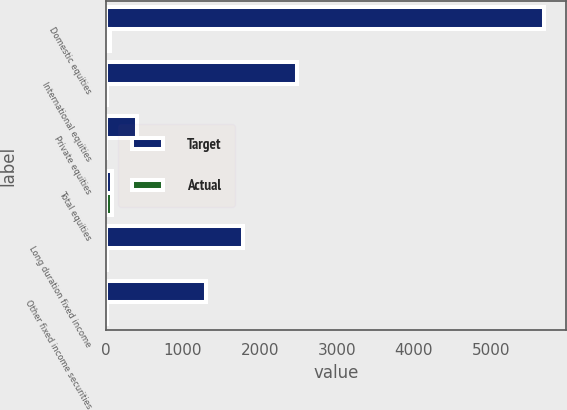<chart> <loc_0><loc_0><loc_500><loc_500><stacked_bar_chart><ecel><fcel>Domestic equities<fcel>International equities<fcel>Private equities<fcel>Total equities<fcel>Long duration fixed income<fcel>Other fixed income securities<nl><fcel>Target<fcel>5694<fcel>2481<fcel>406<fcel>75<fcel>1778<fcel>1302<nl><fcel>Actual<fcel>53<fcel>17<fcel>5<fcel>75<fcel>15<fcel>10<nl></chart> 